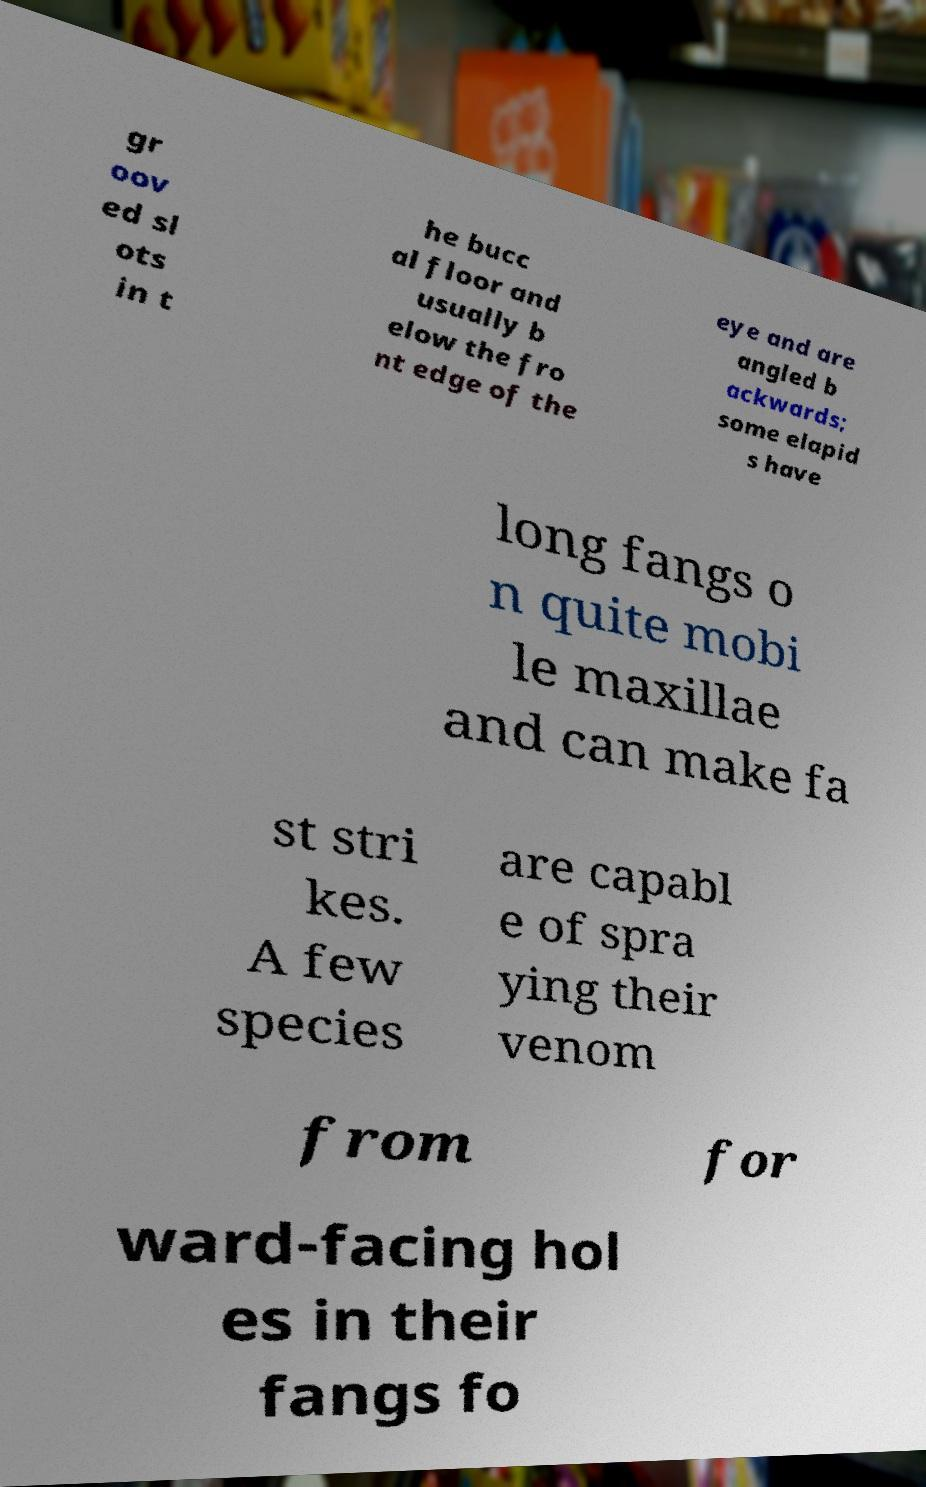For documentation purposes, I need the text within this image transcribed. Could you provide that? gr oov ed sl ots in t he bucc al floor and usually b elow the fro nt edge of the eye and are angled b ackwards; some elapid s have long fangs o n quite mobi le maxillae and can make fa st stri kes. A few species are capabl e of spra ying their venom from for ward-facing hol es in their fangs fo 